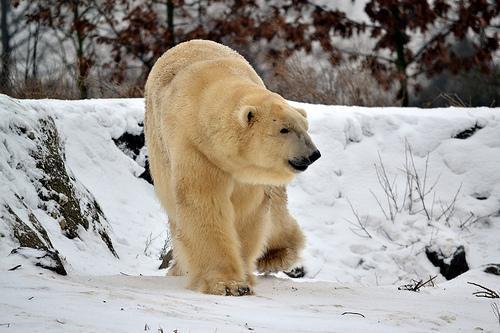How many polar bears are shown?
Give a very brief answer. 1. 